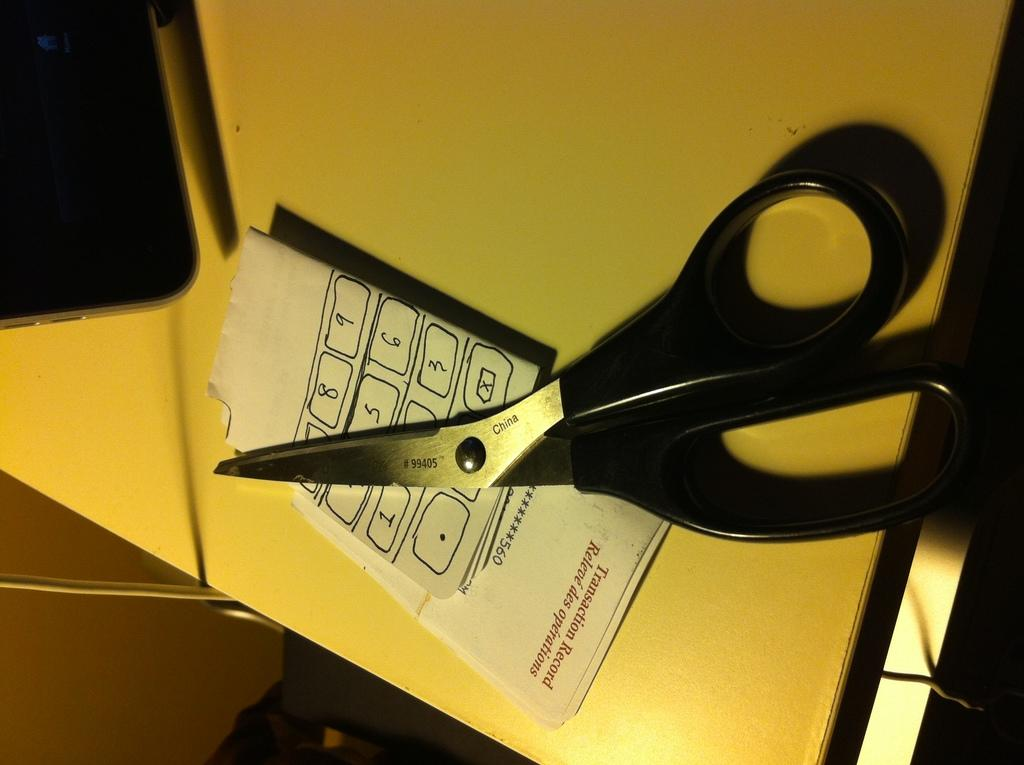What object is used for cutting in the image? There are scissors in the image. What is being cut or prepared with the scissors? There is a paper in the image. Where are the scissors and paper located? The scissors and paper are on a table. What type of kitten is being treated by the cook in the image? There is no kitten or cook present in the image; it only features scissors and paper on a table. 